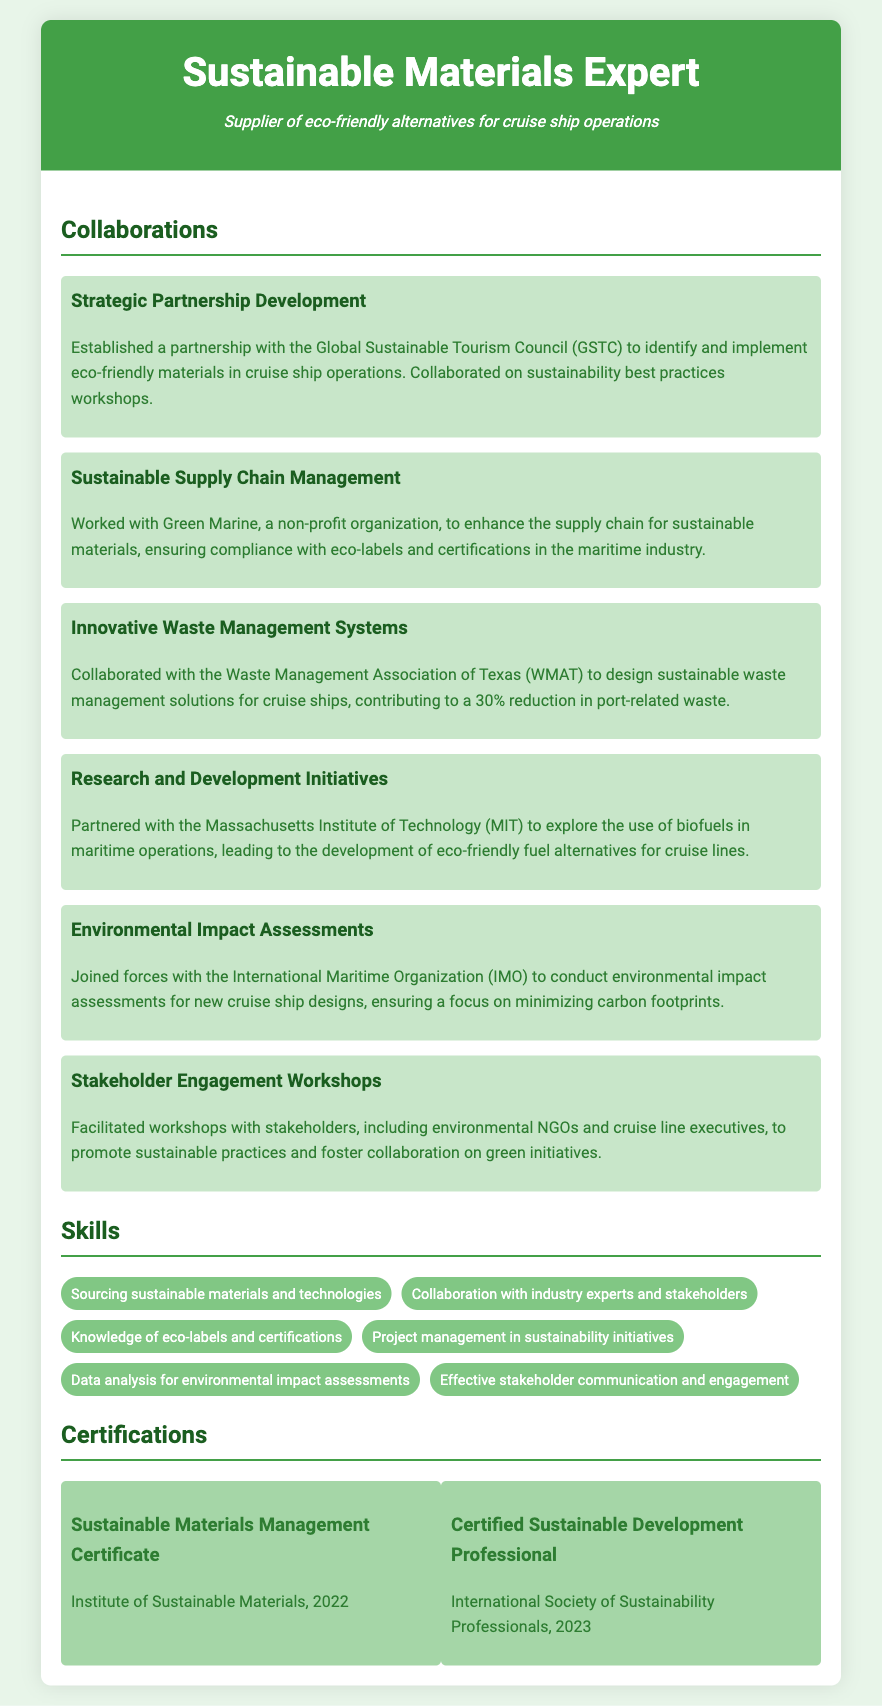what is the title of the document? The title of the document typically reflects the profession or expertise of the individual, which here is "Sustainable Materials Expert."
Answer: Sustainable Materials Expert what organization did the expert partner with for eco-friendly materials? The document mentions a strategic partnership with the Global Sustainable Tourism Council for eco-friendly materials in cruise ship operations.
Answer: Global Sustainable Tourism Council how much reduction in port-related waste was achieved through waste management solutions? The collaboration with the Waste Management Association of Texas contributed to a 30% reduction in port-related waste.
Answer: 30% which institution was involved in the research and development initiatives? The collaboration for research and development initiatives was done with the Massachusetts Institute of Technology.
Answer: Massachusetts Institute of Technology what are the two certifications mentioned in the document? The document lists two certifications: "Sustainable Materials Management Certificate" and "Certified Sustainable Development Professional."
Answer: Sustainable Materials Management Certificate, Certified Sustainable Development Professional what type of workshops did the expert facilitate? The expert facilitated stakeholder engagement workshops with various groups to promote sustainable practices.
Answer: Stakeholder engagement workshops which organization did the expert join for environmental impact assessments? The expert collaborated with the International Maritime Organization for conducting environmental impact assessments.
Answer: International Maritime Organization name one skill listed in the CV related to project management. One of the skills related to project management in sustainability initiatives is explicitly mentioned in the document.
Answer: Project management in sustainability initiatives 